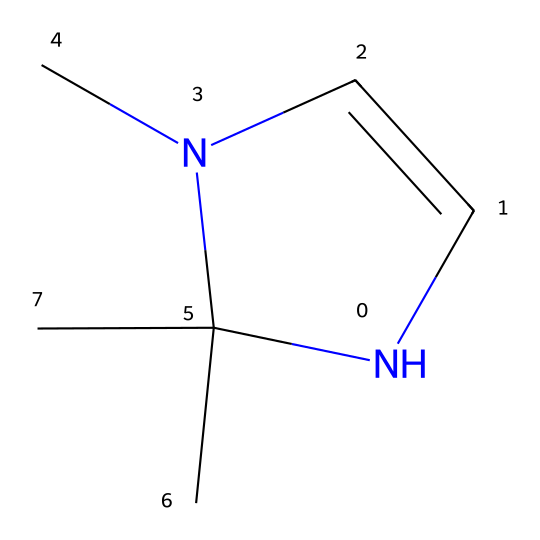How many nitrogen atoms are present in Arduengo carbene? The SMILES representation shows one nitrogen atom in the cyclic structure, confirming the presence of one nitrogen.
Answer: one What is the total number of carbon atoms in Arduengo carbene? By analyzing the SMILES, there are five carbon atoms indicated in the structure (three in the ring and two as branches).
Answer: five What type of chemical compound is Arduengo carbene classified as? Given its structure, which includes a stable N-heterocyclic ring with a nitrogen, Arduengo carbene is classified as a carbene.
Answer: carbene How many double bonds are present in the structure of Arduengo carbene? The structure contains one double bond between the nitrogen and the adjacent carbon in the cyclic part, while other connections are single bonds.
Answer: one What is the hybridization of the nitrogen atom in Arduengo carbene? The nitrogen in the heterocyclic structure is involved in forming a double bond with one of the carbon atoms while having a lone pair, suggesting it has sp2 hybridization.
Answer: sp2 In what kind of reactions is Arduengo carbene potentially effective? Due to its stability and unique electronic properties, Arduengo carbene is potentially effective in facilitating catalysis in various chemical reactions.
Answer: catalysis 